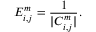Convert formula to latex. <formula><loc_0><loc_0><loc_500><loc_500>E _ { i , j } ^ { m } = \frac { 1 } { | C _ { i , j } ^ { m } | } .</formula> 